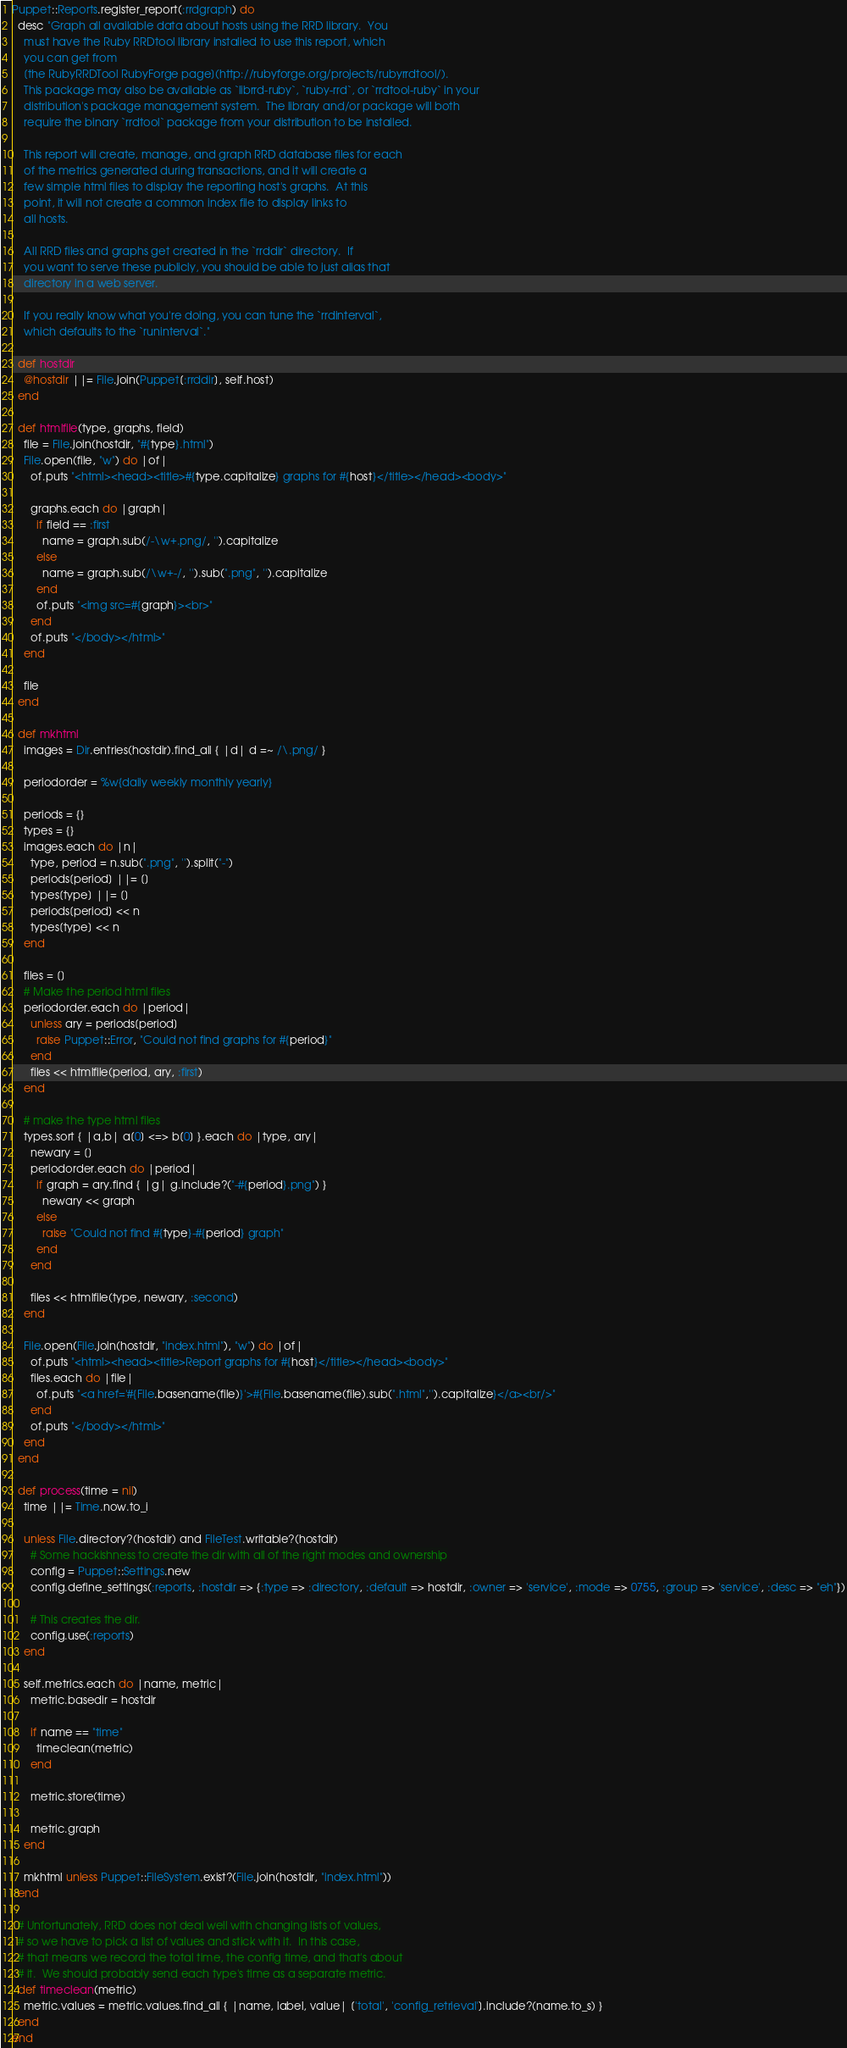<code> <loc_0><loc_0><loc_500><loc_500><_Ruby_>Puppet::Reports.register_report(:rrdgraph) do
  desc "Graph all available data about hosts using the RRD library.  You
    must have the Ruby RRDtool library installed to use this report, which
    you can get from
    [the RubyRRDTool RubyForge page](http://rubyforge.org/projects/rubyrrdtool/).
    This package may also be available as `librrd-ruby`, `ruby-rrd`, or `rrdtool-ruby` in your
    distribution's package management system.  The library and/or package will both
    require the binary `rrdtool` package from your distribution to be installed.

    This report will create, manage, and graph RRD database files for each
    of the metrics generated during transactions, and it will create a
    few simple html files to display the reporting host's graphs.  At this
    point, it will not create a common index file to display links to
    all hosts.

    All RRD files and graphs get created in the `rrddir` directory.  If
    you want to serve these publicly, you should be able to just alias that
    directory in a web server.

    If you really know what you're doing, you can tune the `rrdinterval`,
    which defaults to the `runinterval`."

  def hostdir
    @hostdir ||= File.join(Puppet[:rrddir], self.host)
  end

  def htmlfile(type, graphs, field)
    file = File.join(hostdir, "#{type}.html")
    File.open(file, "w") do |of|
      of.puts "<html><head><title>#{type.capitalize} graphs for #{host}</title></head><body>"

      graphs.each do |graph|
        if field == :first
          name = graph.sub(/-\w+.png/, '').capitalize
        else
          name = graph.sub(/\w+-/, '').sub(".png", '').capitalize
        end
        of.puts "<img src=#{graph}><br>"
      end
      of.puts "</body></html>"
    end

    file
  end

  def mkhtml
    images = Dir.entries(hostdir).find_all { |d| d =~ /\.png/ }

    periodorder = %w{daily weekly monthly yearly}

    periods = {}
    types = {}
    images.each do |n|
      type, period = n.sub(".png", '').split("-")
      periods[period] ||= []
      types[type] ||= []
      periods[period] << n
      types[type] << n
    end

    files = []
    # Make the period html files
    periodorder.each do |period|
      unless ary = periods[period]
        raise Puppet::Error, "Could not find graphs for #{period}"
      end
      files << htmlfile(period, ary, :first)
    end

    # make the type html files
    types.sort { |a,b| a[0] <=> b[0] }.each do |type, ary|
      newary = []
      periodorder.each do |period|
        if graph = ary.find { |g| g.include?("-#{period}.png") }
          newary << graph
        else
          raise "Could not find #{type}-#{period} graph"
        end
      end

      files << htmlfile(type, newary, :second)
    end

    File.open(File.join(hostdir, "index.html"), "w") do |of|
      of.puts "<html><head><title>Report graphs for #{host}</title></head><body>"
      files.each do |file|
        of.puts "<a href='#{File.basename(file)}'>#{File.basename(file).sub(".html",'').capitalize}</a><br/>"
      end
      of.puts "</body></html>"
    end
  end

  def process(time = nil)
    time ||= Time.now.to_i

    unless File.directory?(hostdir) and FileTest.writable?(hostdir)
      # Some hackishness to create the dir with all of the right modes and ownership
      config = Puppet::Settings.new
      config.define_settings(:reports, :hostdir => {:type => :directory, :default => hostdir, :owner => 'service', :mode => 0755, :group => 'service', :desc => "eh"})

      # This creates the dir.
      config.use(:reports)
    end

    self.metrics.each do |name, metric|
      metric.basedir = hostdir

      if name == "time"
        timeclean(metric)
      end

      metric.store(time)

      metric.graph
    end

    mkhtml unless Puppet::FileSystem.exist?(File.join(hostdir, "index.html"))
  end

  # Unfortunately, RRD does not deal well with changing lists of values,
  # so we have to pick a list of values and stick with it.  In this case,
  # that means we record the total time, the config time, and that's about
  # it.  We should probably send each type's time as a separate metric.
  def timeclean(metric)
    metric.values = metric.values.find_all { |name, label, value| ['total', 'config_retrieval'].include?(name.to_s) }
  end
end

</code> 